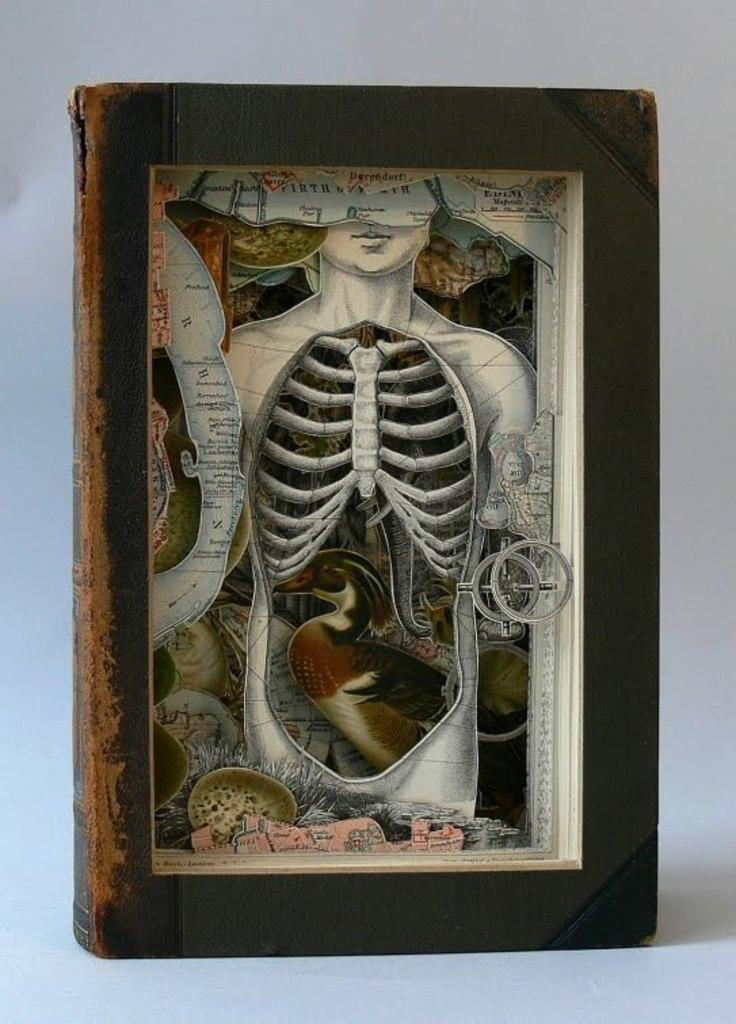What object can be seen in the image? There is a book in the image. What type of hammer is being used to read the book in the image? There is no hammer present in the image; it only features a book. Is the person wearing a hat while reading the book in the image? There is no person or hat present in the image; it only features a book. 